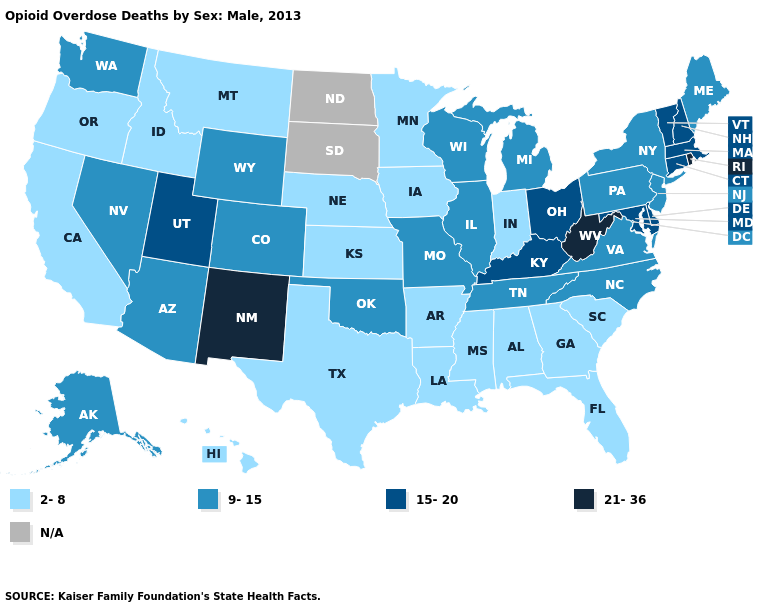Name the states that have a value in the range 21-36?
Answer briefly. New Mexico, Rhode Island, West Virginia. Name the states that have a value in the range N/A?
Answer briefly. North Dakota, South Dakota. Name the states that have a value in the range 15-20?
Quick response, please. Connecticut, Delaware, Kentucky, Maryland, Massachusetts, New Hampshire, Ohio, Utah, Vermont. What is the highest value in the USA?
Answer briefly. 21-36. Among the states that border Maryland , which have the lowest value?
Give a very brief answer. Pennsylvania, Virginia. Does Vermont have the lowest value in the Northeast?
Write a very short answer. No. What is the lowest value in the USA?
Give a very brief answer. 2-8. Does the map have missing data?
Give a very brief answer. Yes. Name the states that have a value in the range 15-20?
Quick response, please. Connecticut, Delaware, Kentucky, Maryland, Massachusetts, New Hampshire, Ohio, Utah, Vermont. Name the states that have a value in the range 2-8?
Quick response, please. Alabama, Arkansas, California, Florida, Georgia, Hawaii, Idaho, Indiana, Iowa, Kansas, Louisiana, Minnesota, Mississippi, Montana, Nebraska, Oregon, South Carolina, Texas. What is the highest value in the USA?
Answer briefly. 21-36. Among the states that border Missouri , which have the highest value?
Answer briefly. Kentucky. What is the value of Delaware?
Answer briefly. 15-20. Name the states that have a value in the range 15-20?
Quick response, please. Connecticut, Delaware, Kentucky, Maryland, Massachusetts, New Hampshire, Ohio, Utah, Vermont. 